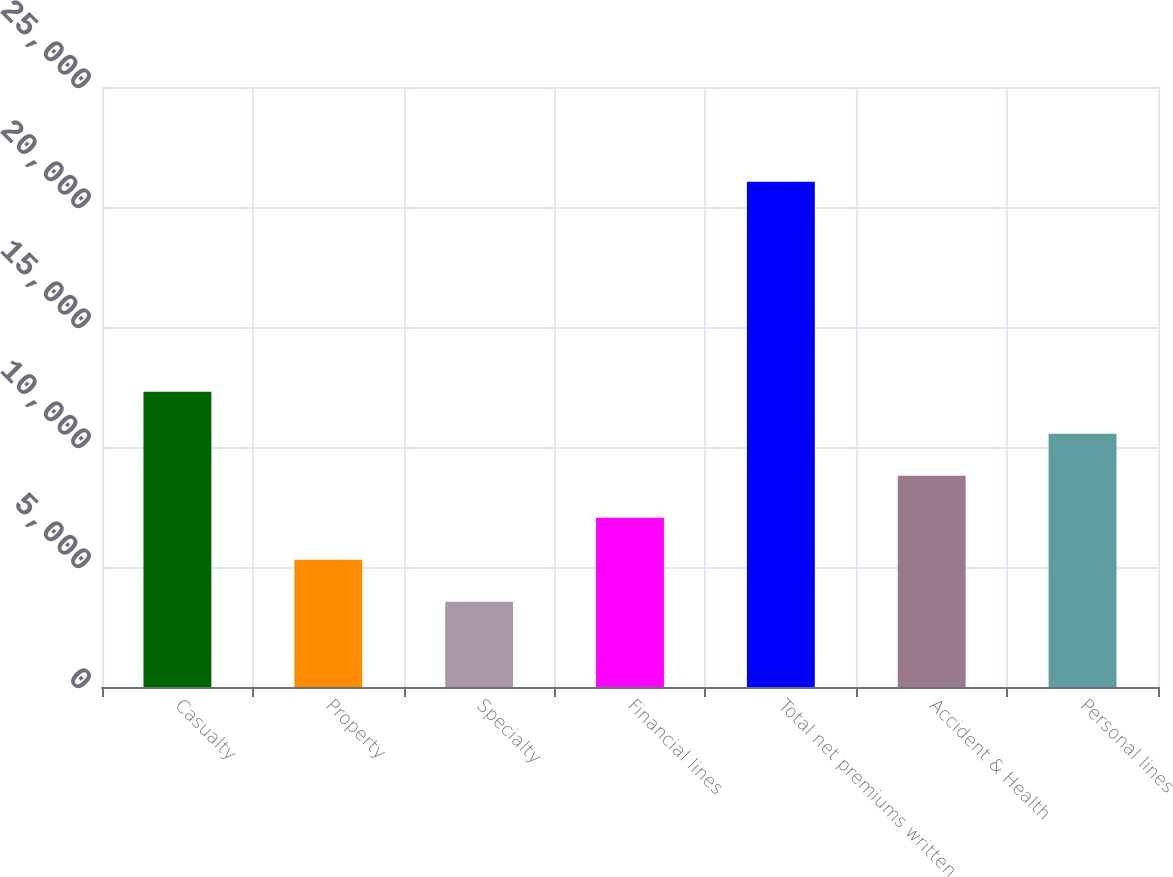<chart> <loc_0><loc_0><loc_500><loc_500><bar_chart><fcel>Casualty<fcel>Property<fcel>Specialty<fcel>Financial lines<fcel>Total net premiums written<fcel>Accident & Health<fcel>Personal lines<nl><fcel>12303.5<fcel>5302.3<fcel>3552<fcel>7052.6<fcel>21055<fcel>8802.9<fcel>10553.2<nl></chart> 